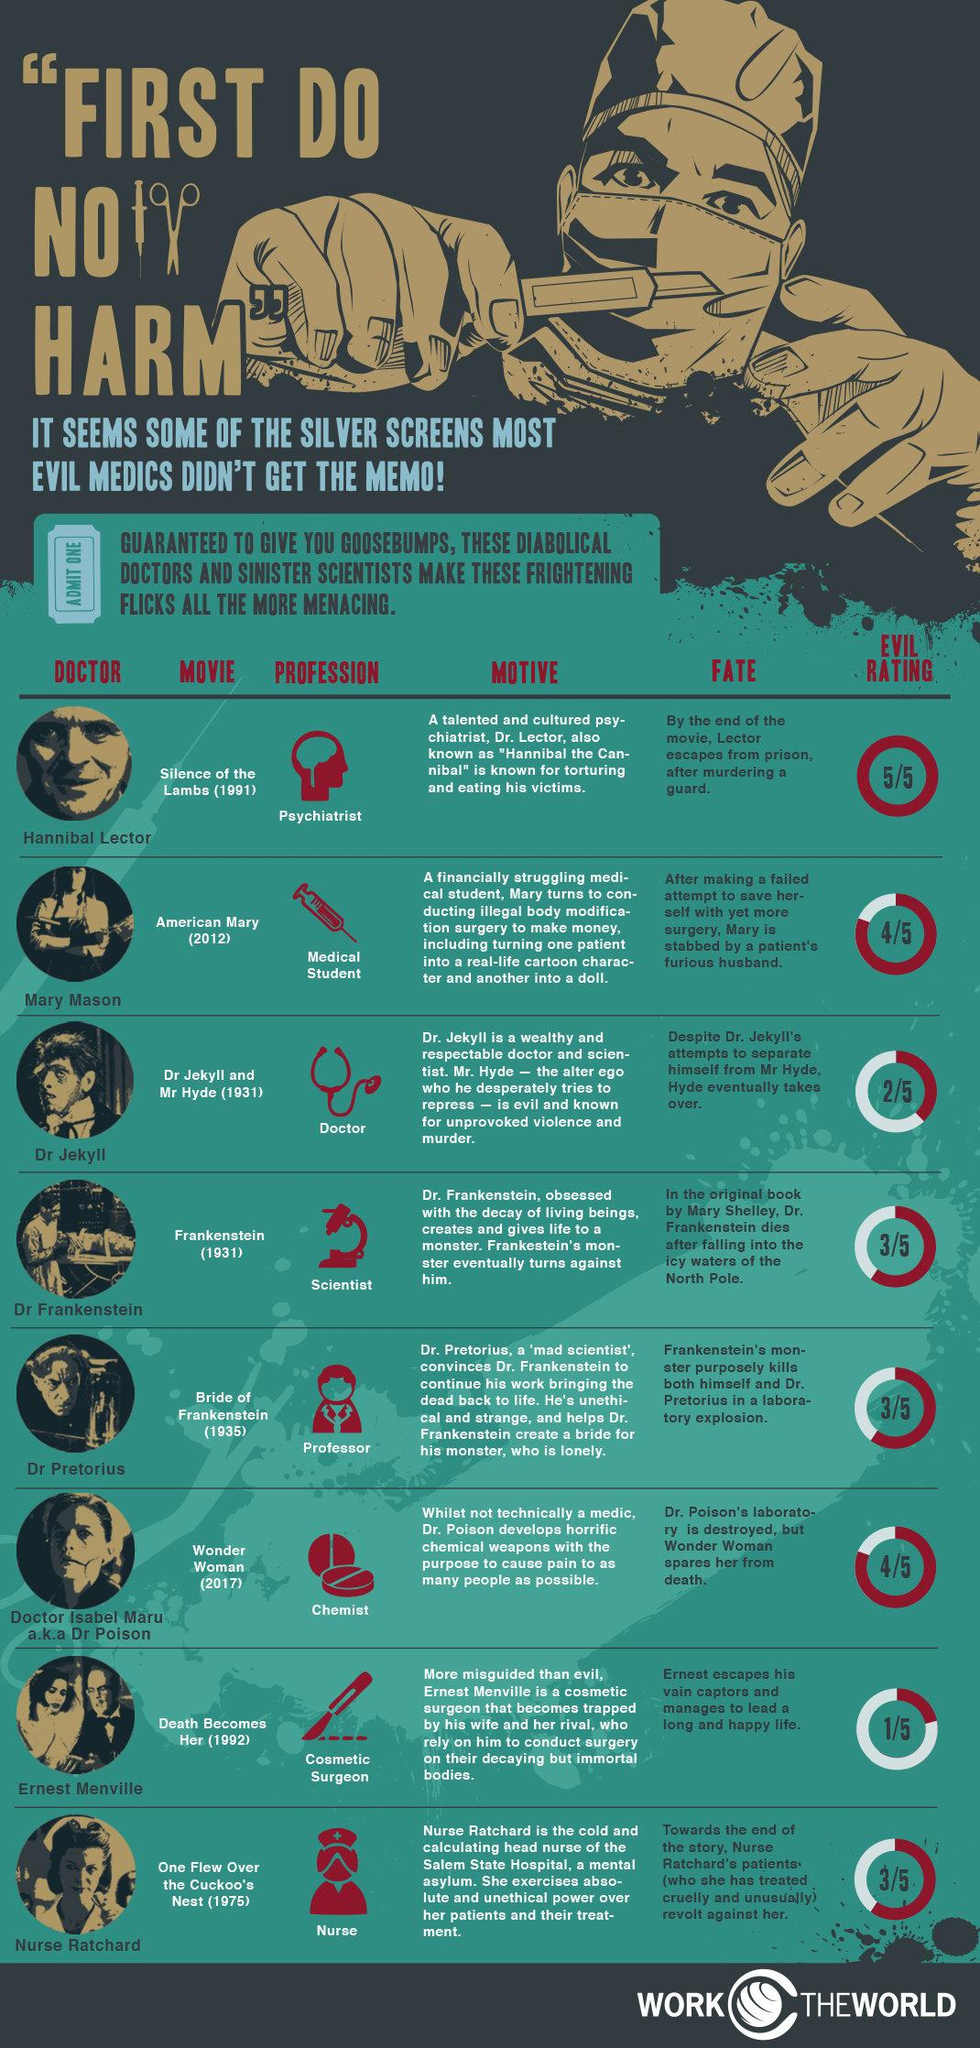Mention a couple of crucial points in this snapshot. Cosmetic surgeon Ernest Menville plays a significant role in the movie "Death Becomes Her. The movie called "Wonder Woman" was released in the year 2017. In the movie 'Bride of Frankenstein,' the role of the professor is played by Dr. Pretorius. The movie 'Frankenstein' was released in 1931. The movie "Wonder Women" has been given an evil rating of 4/5. 